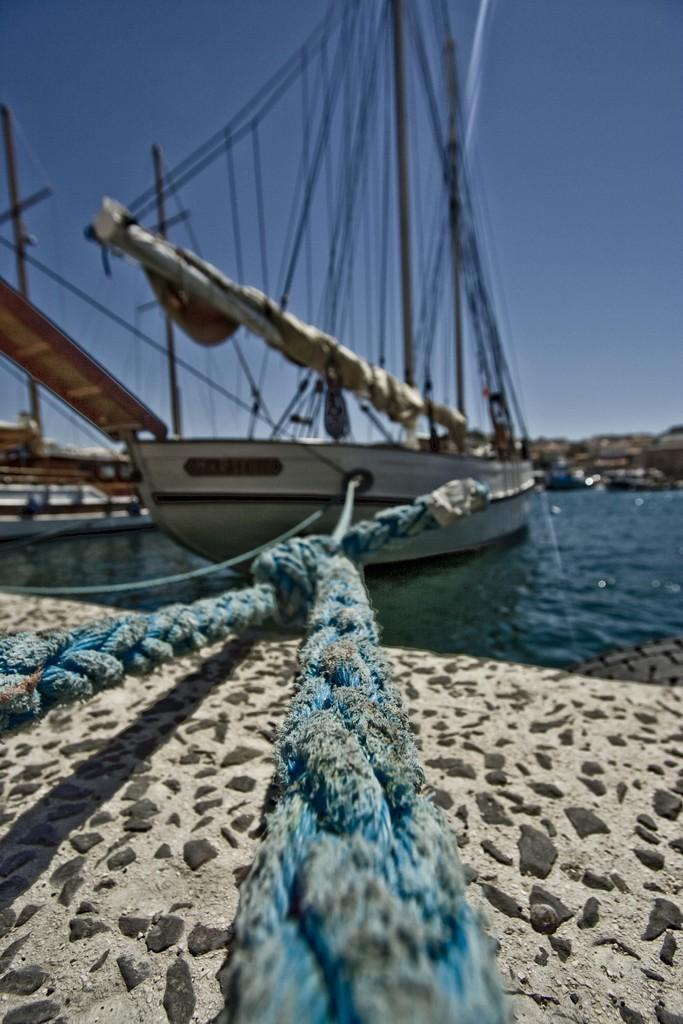What is the main subject of the image? The main subject of the image is a ship. Where is the ship located in the image? The ship is on the water surface in the image. What can be seen attached to the ship? There are two ropes tied to the ship. What type of surface is visible under the ropes? There is a sand surface under the ropes in the image. What else can be seen on the ship? There are a lot of threads tied to a pole on the ship. What type of popcorn is being served on the ship in the image? There is no popcorn present in the image; it features a ship with ropes and threads on a sand surface. 